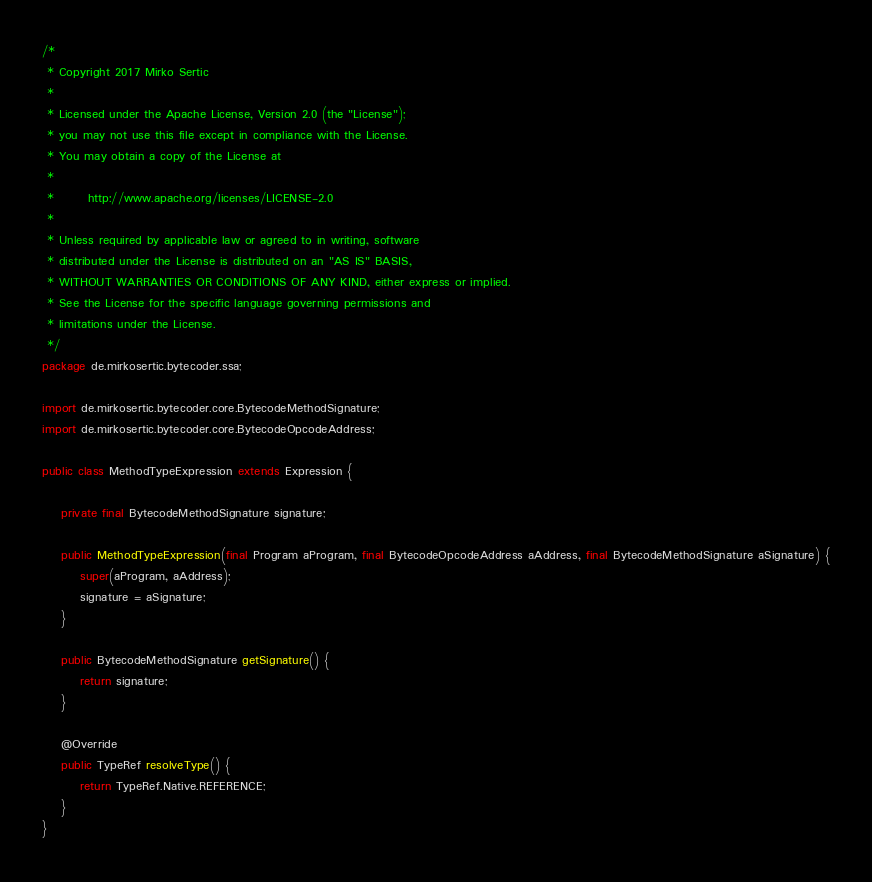Convert code to text. <code><loc_0><loc_0><loc_500><loc_500><_Java_>/*
 * Copyright 2017 Mirko Sertic
 *
 * Licensed under the Apache License, Version 2.0 (the "License");
 * you may not use this file except in compliance with the License.
 * You may obtain a copy of the License at
 *
 *       http://www.apache.org/licenses/LICENSE-2.0
 *
 * Unless required by applicable law or agreed to in writing, software
 * distributed under the License is distributed on an "AS IS" BASIS,
 * WITHOUT WARRANTIES OR CONDITIONS OF ANY KIND, either express or implied.
 * See the License for the specific language governing permissions and
 * limitations under the License.
 */
package de.mirkosertic.bytecoder.ssa;

import de.mirkosertic.bytecoder.core.BytecodeMethodSignature;
import de.mirkosertic.bytecoder.core.BytecodeOpcodeAddress;

public class MethodTypeExpression extends Expression {

    private final BytecodeMethodSignature signature;

    public MethodTypeExpression(final Program aProgram, final BytecodeOpcodeAddress aAddress, final BytecodeMethodSignature aSignature) {
        super(aProgram, aAddress);
        signature = aSignature;
    }

    public BytecodeMethodSignature getSignature() {
        return signature;
    }

    @Override
    public TypeRef resolveType() {
        return TypeRef.Native.REFERENCE;
    }
}
</code> 